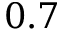<formula> <loc_0><loc_0><loc_500><loc_500>0 . 7</formula> 